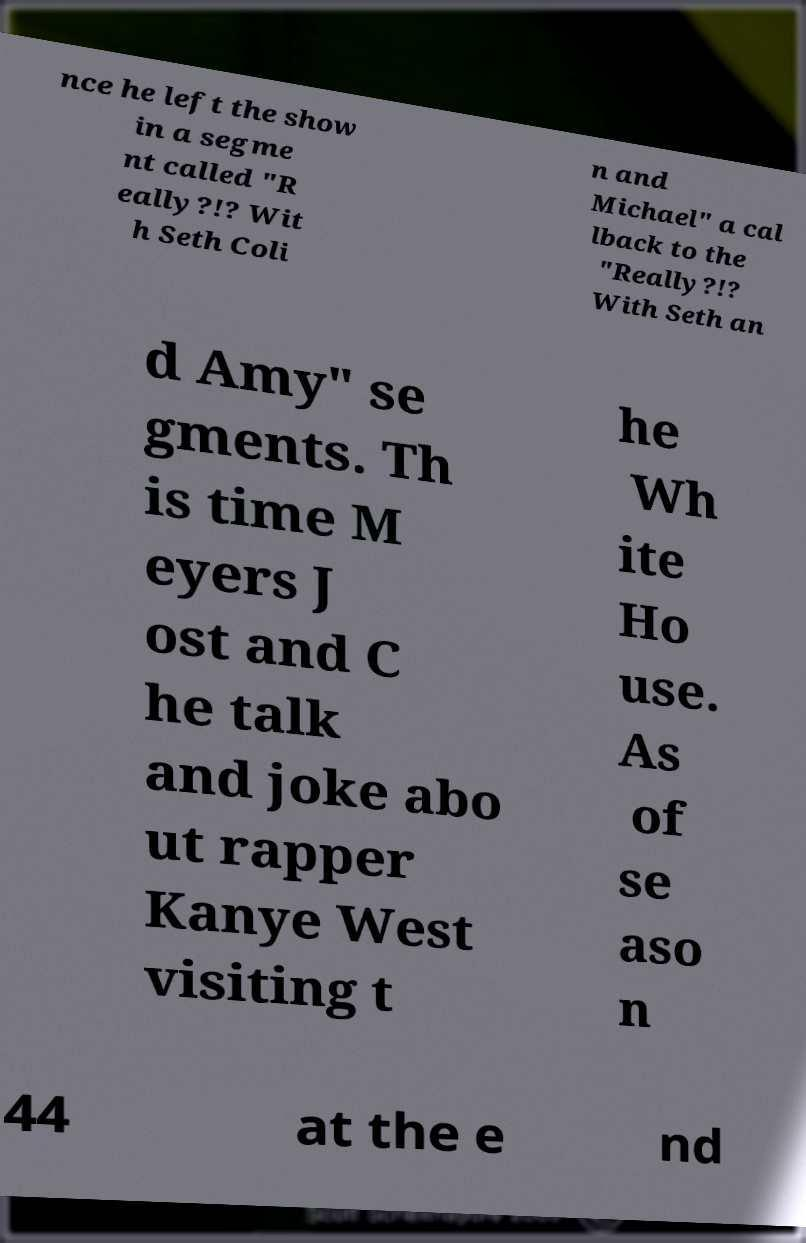Please identify and transcribe the text found in this image. nce he left the show in a segme nt called "R eally?!? Wit h Seth Coli n and Michael" a cal lback to the "Really?!? With Seth an d Amy" se gments. Th is time M eyers J ost and C he talk and joke abo ut rapper Kanye West visiting t he Wh ite Ho use. As of se aso n 44 at the e nd 